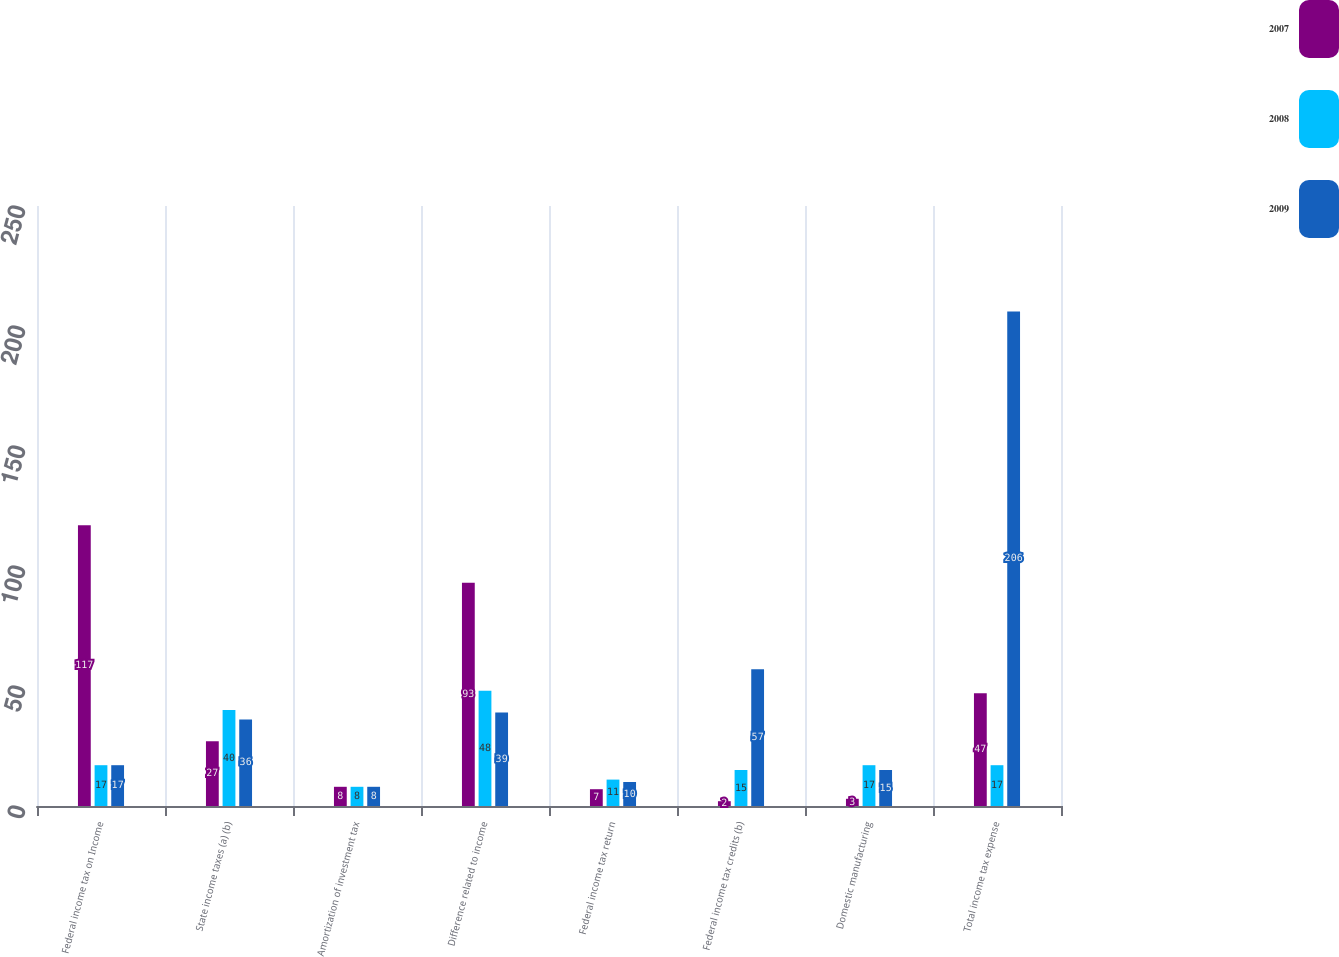Convert chart to OTSL. <chart><loc_0><loc_0><loc_500><loc_500><stacked_bar_chart><ecel><fcel>Federal income tax on Income<fcel>State income taxes (a) (b)<fcel>Amortization of investment tax<fcel>Difference related to income<fcel>Federal income tax return<fcel>Federal income tax credits (b)<fcel>Domestic manufacturing<fcel>Total income tax expense<nl><fcel>2007<fcel>117<fcel>27<fcel>8<fcel>93<fcel>7<fcel>2<fcel>3<fcel>47<nl><fcel>2008<fcel>17<fcel>40<fcel>8<fcel>48<fcel>11<fcel>15<fcel>17<fcel>17<nl><fcel>2009<fcel>17<fcel>36<fcel>8<fcel>39<fcel>10<fcel>57<fcel>15<fcel>206<nl></chart> 